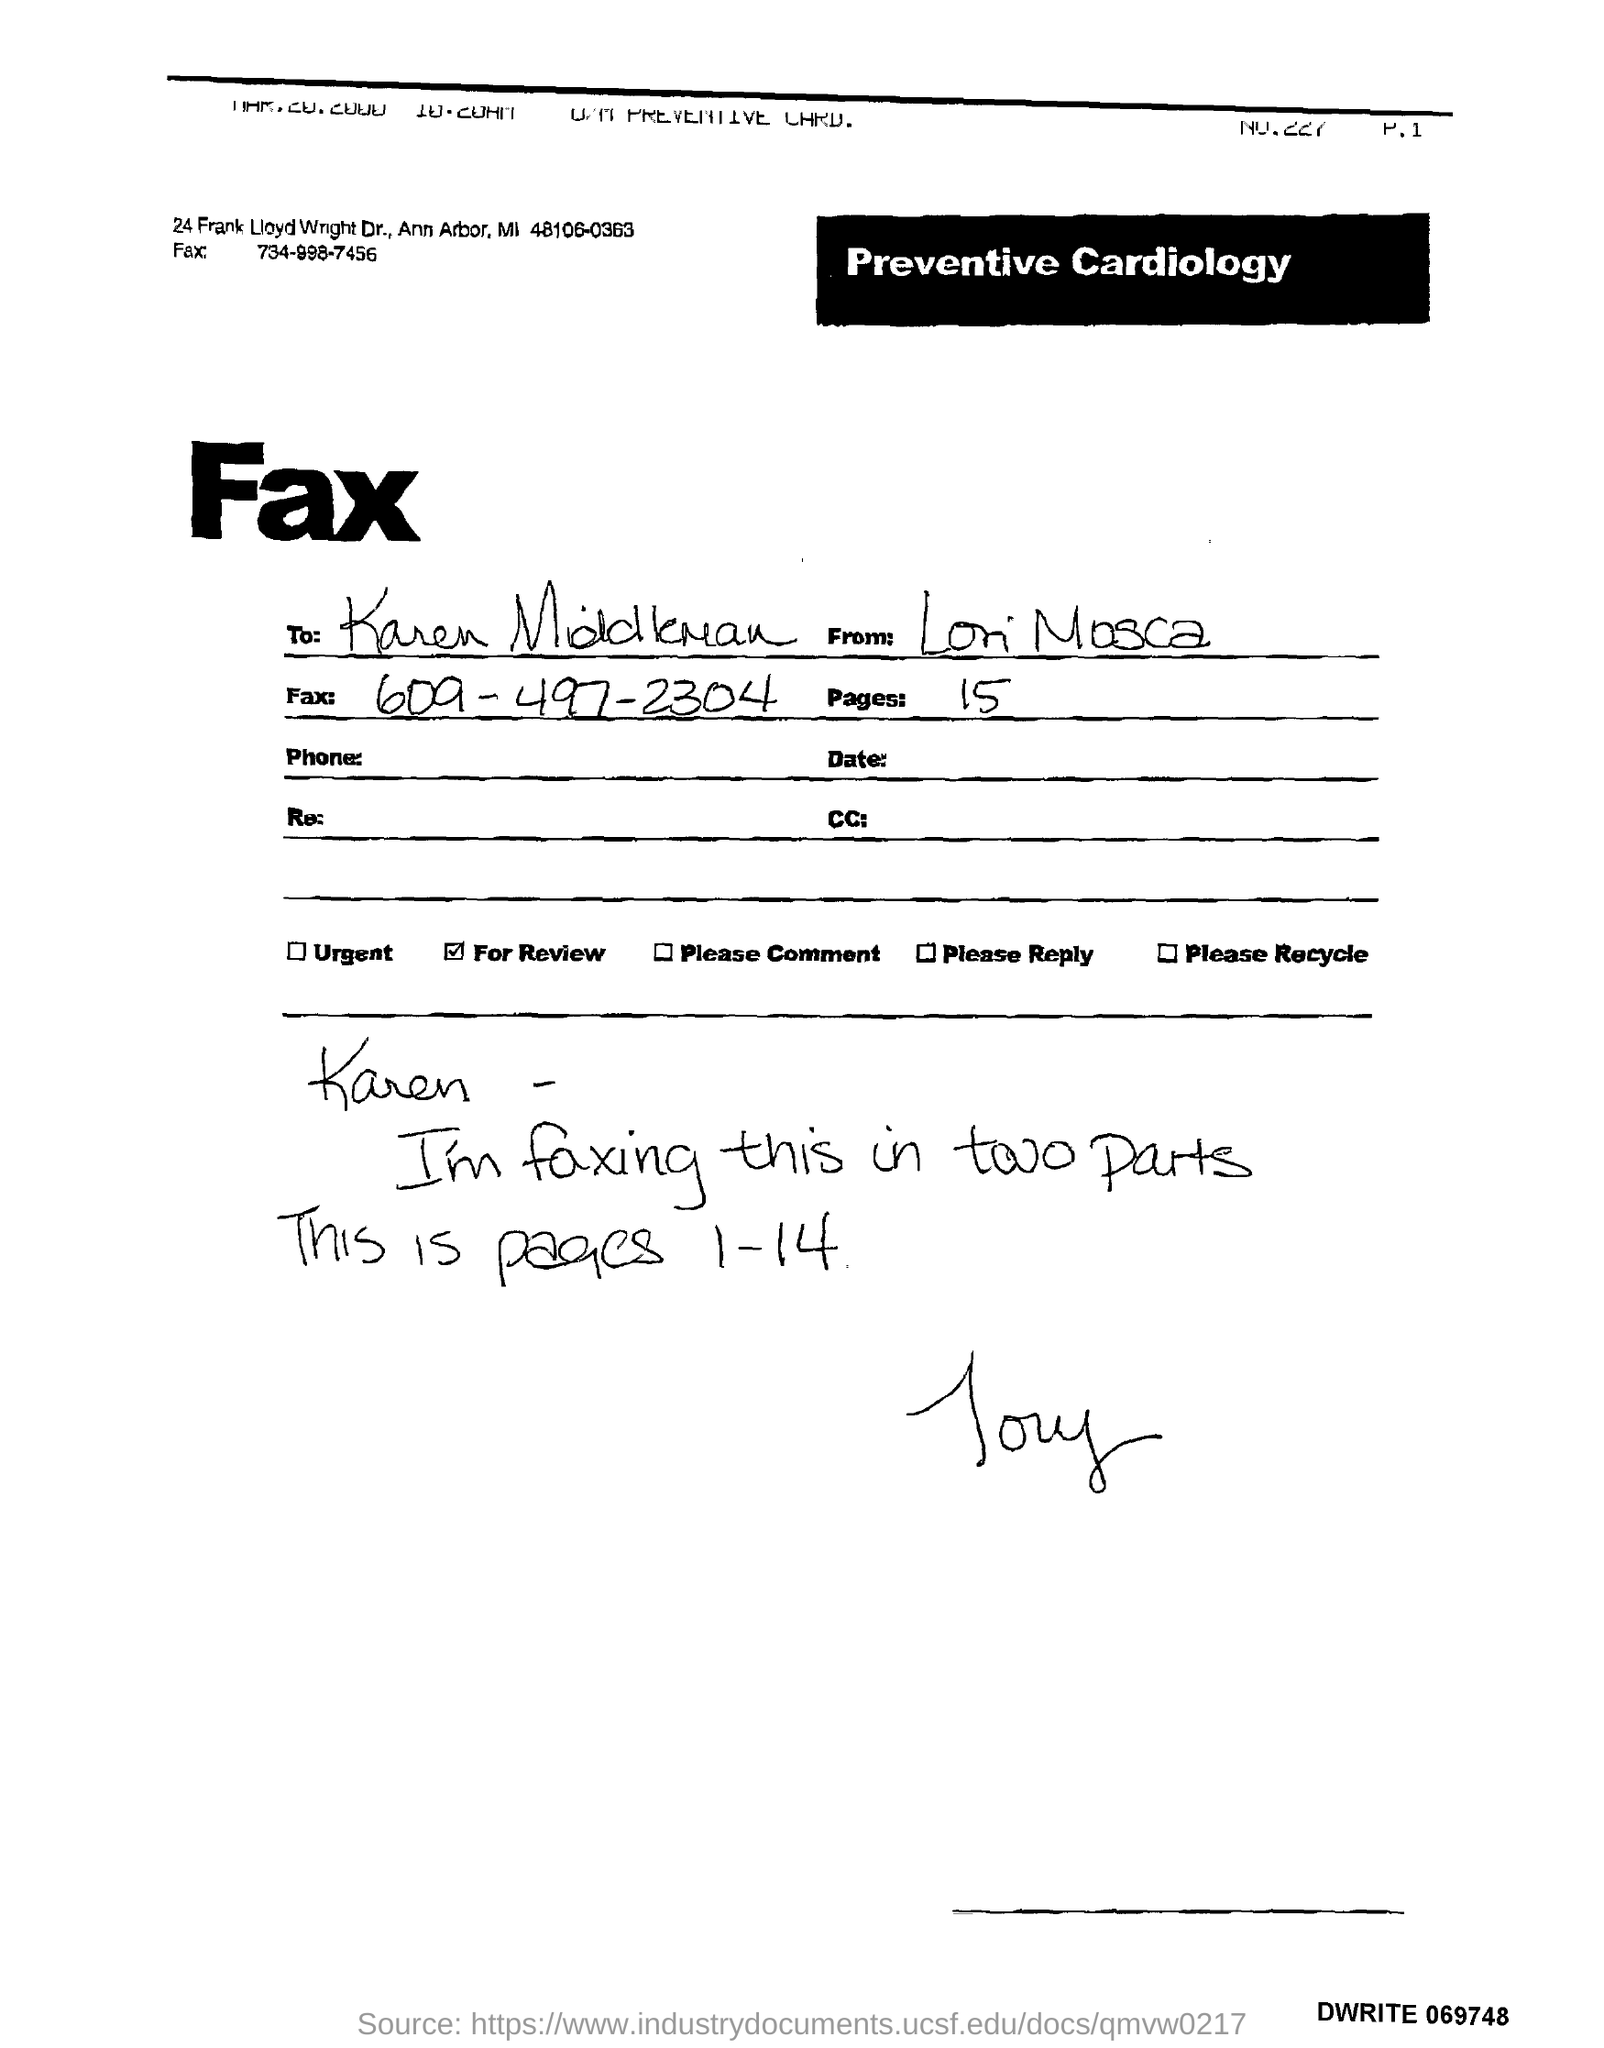List a handful of essential elements in this visual. The sender is Lori Mosca. 